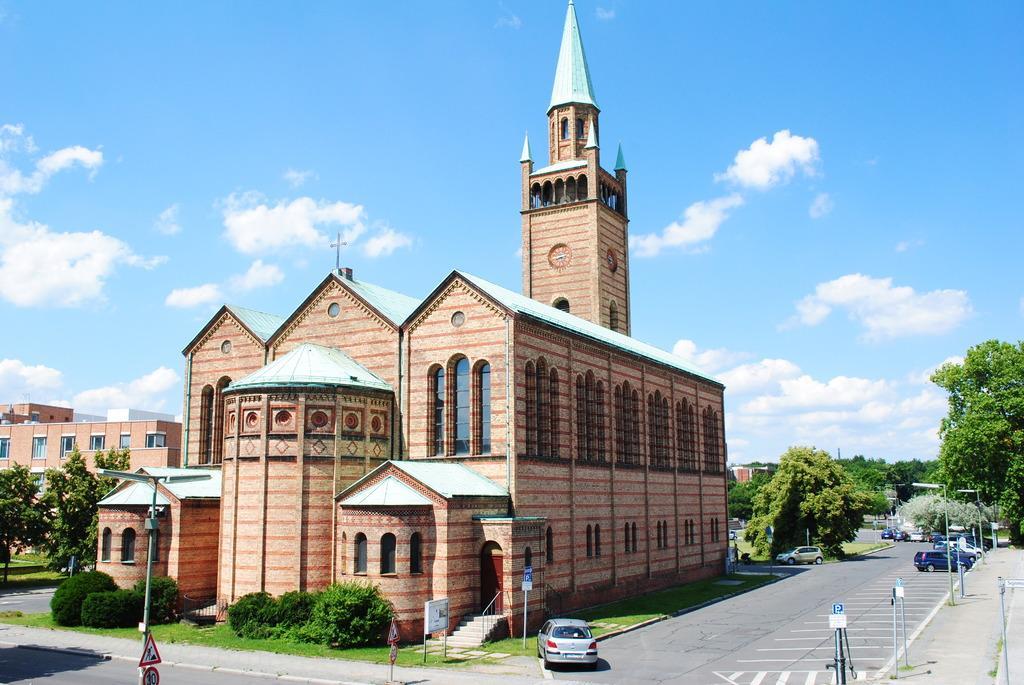In one or two sentences, can you explain what this image depicts? In this picture there is a building in the center of the image and there is another building on the left side of the image, there are trees on the right and left side of the image, there are cars on the right and in the center of the image. 